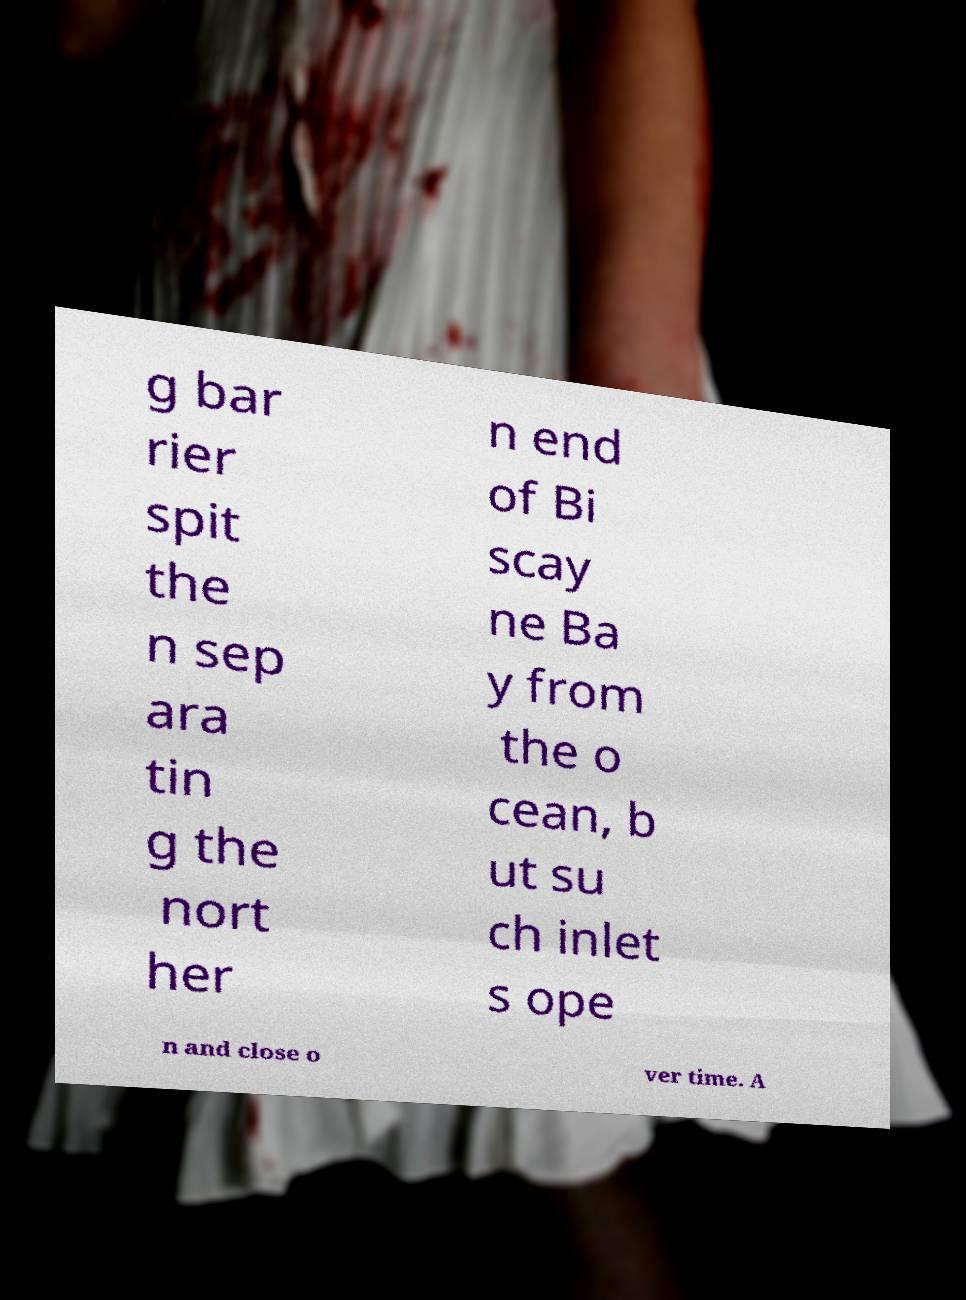What messages or text are displayed in this image? I need them in a readable, typed format. g bar rier spit the n sep ara tin g the nort her n end of Bi scay ne Ba y from the o cean, b ut su ch inlet s ope n and close o ver time. A 